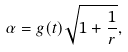<formula> <loc_0><loc_0><loc_500><loc_500>\alpha = g ( t ) \sqrt { 1 + \frac { 1 } { r } } ,</formula> 